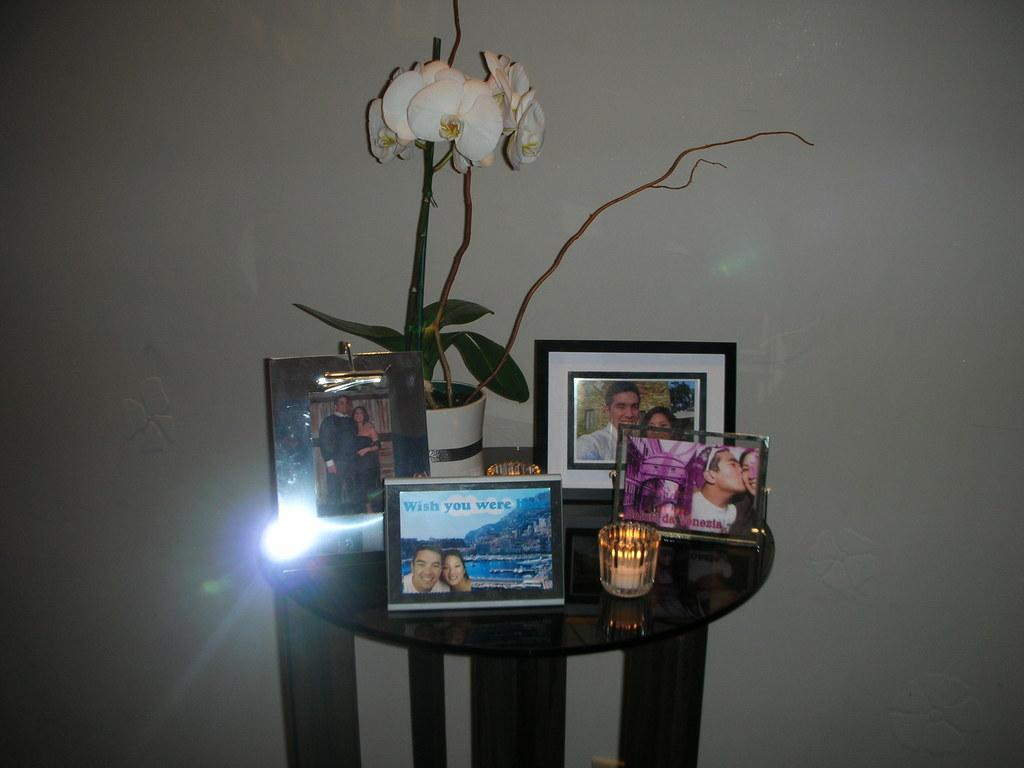Provide a one-sentence caption for the provided image. A small table filled with photo frames and a photo with a couple that says Wish you were here. 